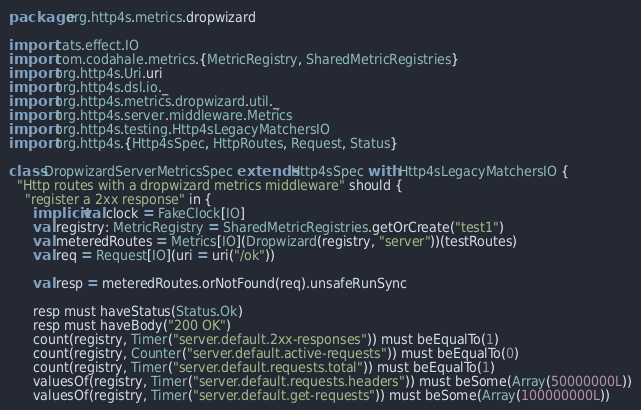Convert code to text. <code><loc_0><loc_0><loc_500><loc_500><_Scala_>package org.http4s.metrics.dropwizard

import cats.effect.IO
import com.codahale.metrics.{MetricRegistry, SharedMetricRegistries}
import org.http4s.Uri.uri
import org.http4s.dsl.io._
import org.http4s.metrics.dropwizard.util._
import org.http4s.server.middleware.Metrics
import org.http4s.testing.Http4sLegacyMatchersIO
import org.http4s.{Http4sSpec, HttpRoutes, Request, Status}

class DropwizardServerMetricsSpec extends Http4sSpec with Http4sLegacyMatchersIO {
  "Http routes with a dropwizard metrics middleware" should {
    "register a 2xx response" in {
      implicit val clock = FakeClock[IO]
      val registry: MetricRegistry = SharedMetricRegistries.getOrCreate("test1")
      val meteredRoutes = Metrics[IO](Dropwizard(registry, "server"))(testRoutes)
      val req = Request[IO](uri = uri("/ok"))

      val resp = meteredRoutes.orNotFound(req).unsafeRunSync

      resp must haveStatus(Status.Ok)
      resp must haveBody("200 OK")
      count(registry, Timer("server.default.2xx-responses")) must beEqualTo(1)
      count(registry, Counter("server.default.active-requests")) must beEqualTo(0)
      count(registry, Timer("server.default.requests.total")) must beEqualTo(1)
      valuesOf(registry, Timer("server.default.requests.headers")) must beSome(Array(50000000L))
      valuesOf(registry, Timer("server.default.get-requests")) must beSome(Array(100000000L))</code> 